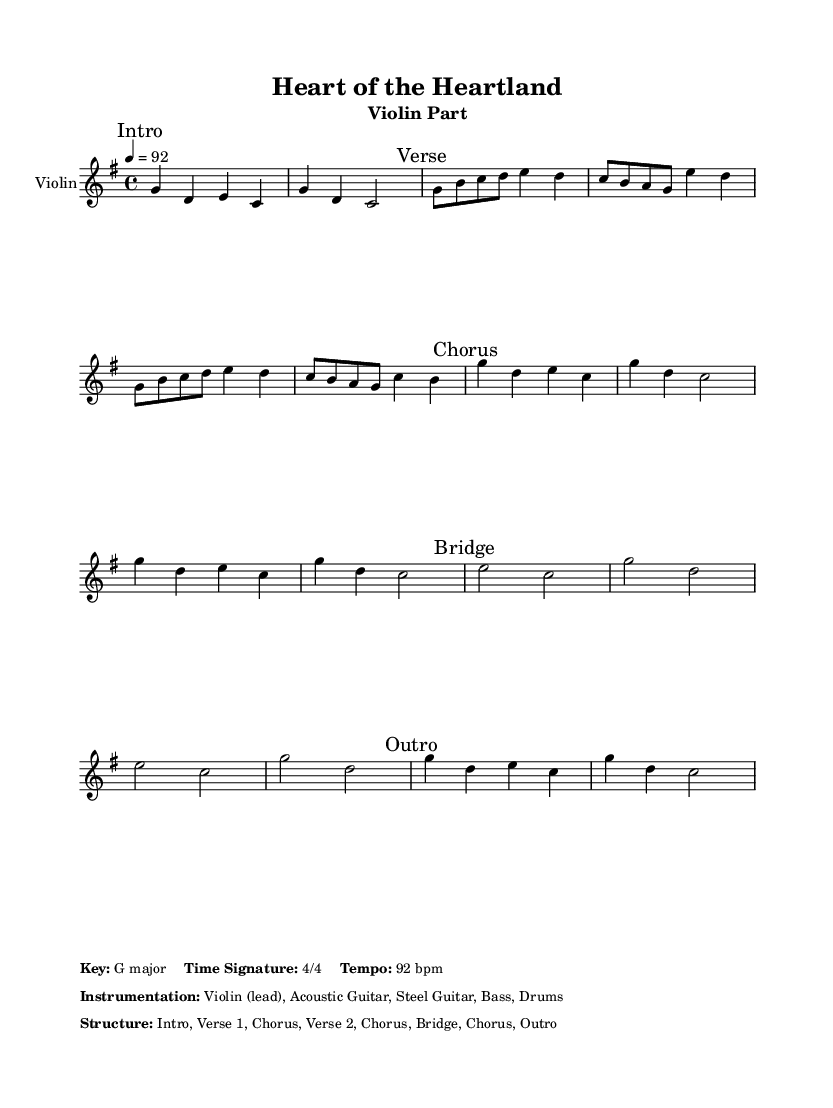What is the key signature of this music? The key signature is indicated at the beginning of the staff with the sharp sign or note indicators. In this case, it shows one sharp which corresponds to G major.
Answer: G major What is the time signature of this piece? The time signature appears next to the key signature and indicates how many beats are in each measure. Here it is marked as 4/4, meaning there are four beats per measure.
Answer: 4/4 What is the tempo marking of this music? The tempo is indicated at the start with the markings like "eighth note equals a number". Here, it states 4 equals 92, indicating that there are 92 beats per minute using quarter note as reference.
Answer: 92 bpm How many sections are in the structure of this piece? The structure is outlined in the markup section with labels such as Intro, Verse, Chorus, Bridge, and Outro listed in order. Counting these labels gives us a total of 8 sections.
Answer: 8 Which instrument plays the lead in this piece? The instrumentation is indicated in the markup section where it states that the violin is the lead instrument, highlighting its prominent role in the music.
Answer: Violin What form does this song follow? The structure is based on the common verse-chorus form typical in country music, alternating between verses and choruses with a bridge in the middle. This specific layout follows the pattern of Intro, Verse 1, Chorus, Verse 2, Chorus, Bridge, Chorus, Outro.
Answer: Verse-Chorus form What type of texture might you expect in this piece, given its instrumentation? The instrumentation includes Violin, Acoustic Guitar, Steel Guitar, Bass, and Drums, suggesting a rich blend of melodic lead lines with harmonic support beneath, typical of country-pop music with a vocal focus.
Answer: Homophonic texture 